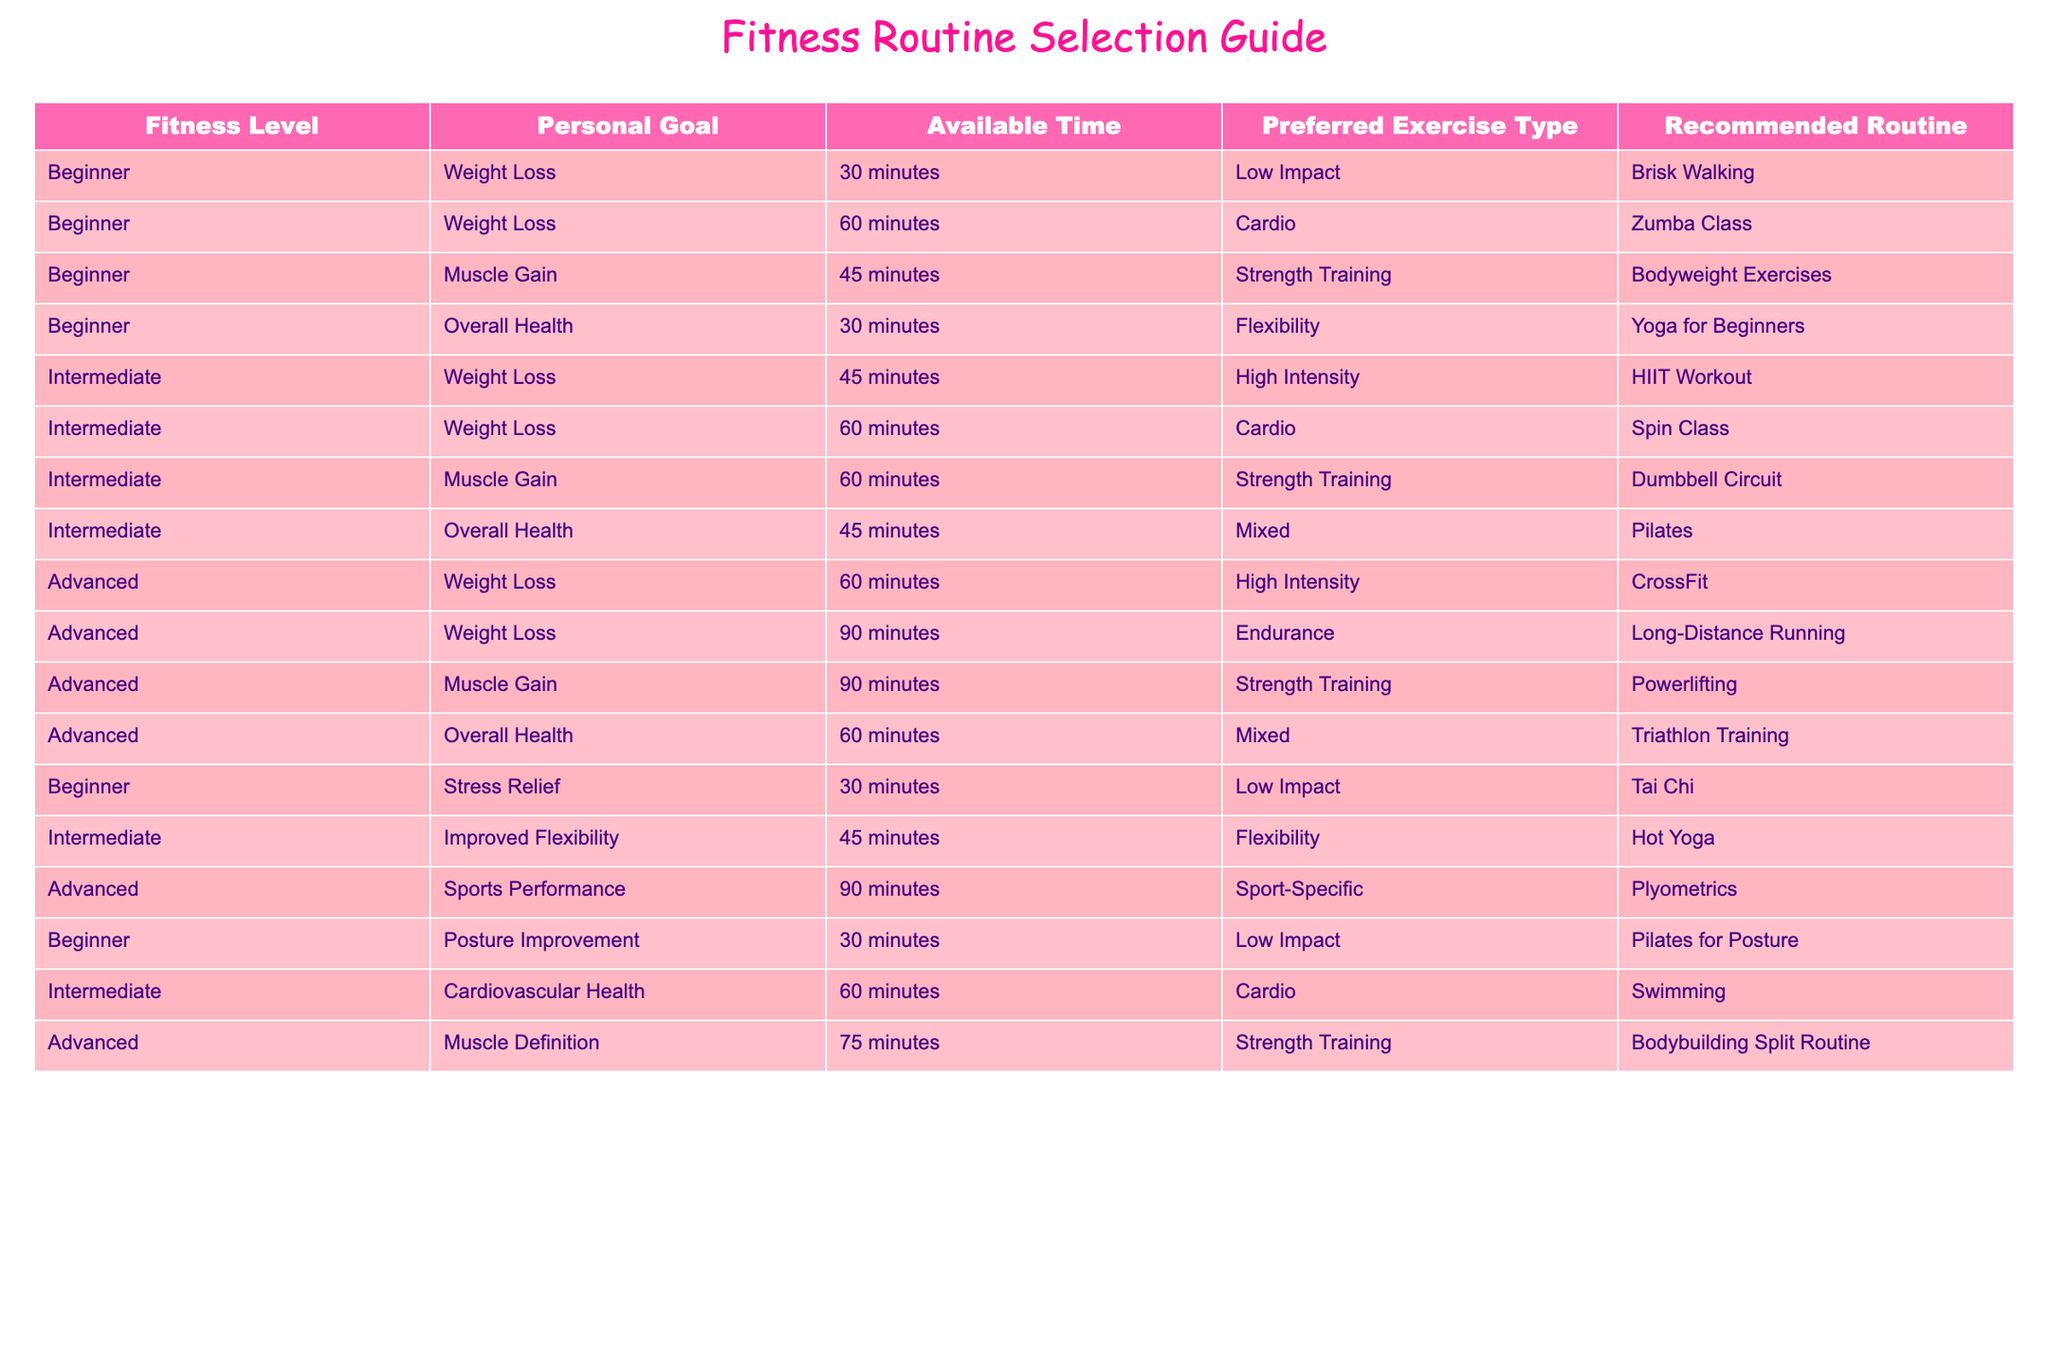What fitness routine is recommended for beginners aiming for weight loss with a time frame of 30 minutes? Looking at the table, I find the row for beginners with a personal goal of weight loss and available time of 30 minutes. That row recommends "Brisk Walking" as the routine.
Answer: Brisk Walking For intermediate individuals focusing on muscle gain, what exercise type is suggested? In the table, I look for intermediate fitness level, muscle gain, and check the corresponding exercise type. It shows that the suggested exercise type is "Strength Training."
Answer: Strength Training What is the recommended routine for advanced individuals with a time availability of 90 minutes aimed at weight loss? Checking the advanced section for a personal goal of weight loss and 90 minutes of available time, I find "Long-Distance Running" as the recommended routine.
Answer: Long-Distance Running Is there a fitness routine recommended for beginners that focuses on stress relief? I search for the beginner's section for stress relief and find that "Tai Chi" is indeed mentioned as a recommended routine, confirming that there is a recommendation.
Answer: Yes What is the difference in recommended routine for an advanced individual targeting muscle definition compared to an intermediate individual targeting muscle gain? First, I identify the advanced routine for muscle definition, which is "Bodybuilding Split Routine". Then, I check the intermediate routine under muscle gain, which is "Dumbbell Circuit". The difference lies in the specific routines suggested for their respective levels and goals, highlighting a more specialized approach in advanced training.
Answer: Bodybuilding Split Routine vs. Dumbbell Circuit Which exercise type appears most frequently for individuals interested in overall health among all fitness levels? I tally the exercise types listed for overall health across different fitness levels. I find that "Mixed" appears twice (for Intermediate and Advanced), while Low Impact and Flexibility appear once each. Therefore, "Mixed" is the most frequent.
Answer: Mixed Are there any routines listed for improving flexibility at an intermediate fitness level? In the intermediate section looking for improved flexibility shows that "Hot Yoga" is the recommended exercise. Hence, there is a routine designated for this goal.
Answer: Yes What is the average amount of time recommended for muscle gain routines across all fitness levels? I first collect the time values for muscle gain: 60 minutes (Intermediate), 90 minutes (Advanced), and 45 minutes (Beginner). Adding them gives 195 total minutes and dividing by 3 gives an average of 65 minutes.
Answer: 65 minutes 